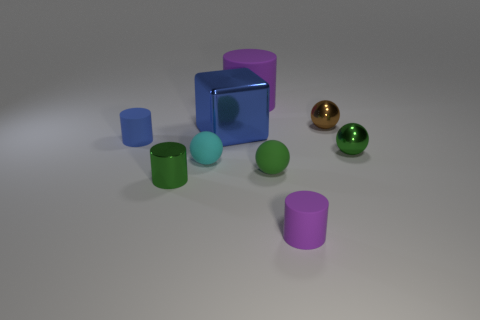What shapes are present and how are they arranged? The image shows a collection of geometric shapes including cubes, cylinders, and spheres. They are casually scattered across a flat surface, implying no specific arrangement or pattern. Do these shapes seem to be of equal size? No, the shapes vary in size. There's a large blue cube that dominates the scene, accompanied by smaller cylinders and spheres, which include a tiny cyan sphere and a small golden one. 